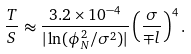Convert formula to latex. <formula><loc_0><loc_0><loc_500><loc_500>\frac { T } { S } \approx \frac { 3 . 2 \times 1 0 ^ { - 4 } } { | \ln ( \phi _ { N } ^ { 2 } / \sigma ^ { 2 } ) | } \left ( \frac { \sigma } { \mp l } \right ) ^ { 4 } .</formula> 